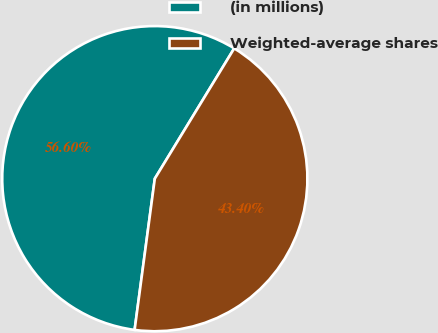Convert chart. <chart><loc_0><loc_0><loc_500><loc_500><pie_chart><fcel>(in millions)<fcel>Weighted-average shares<nl><fcel>56.6%<fcel>43.4%<nl></chart> 